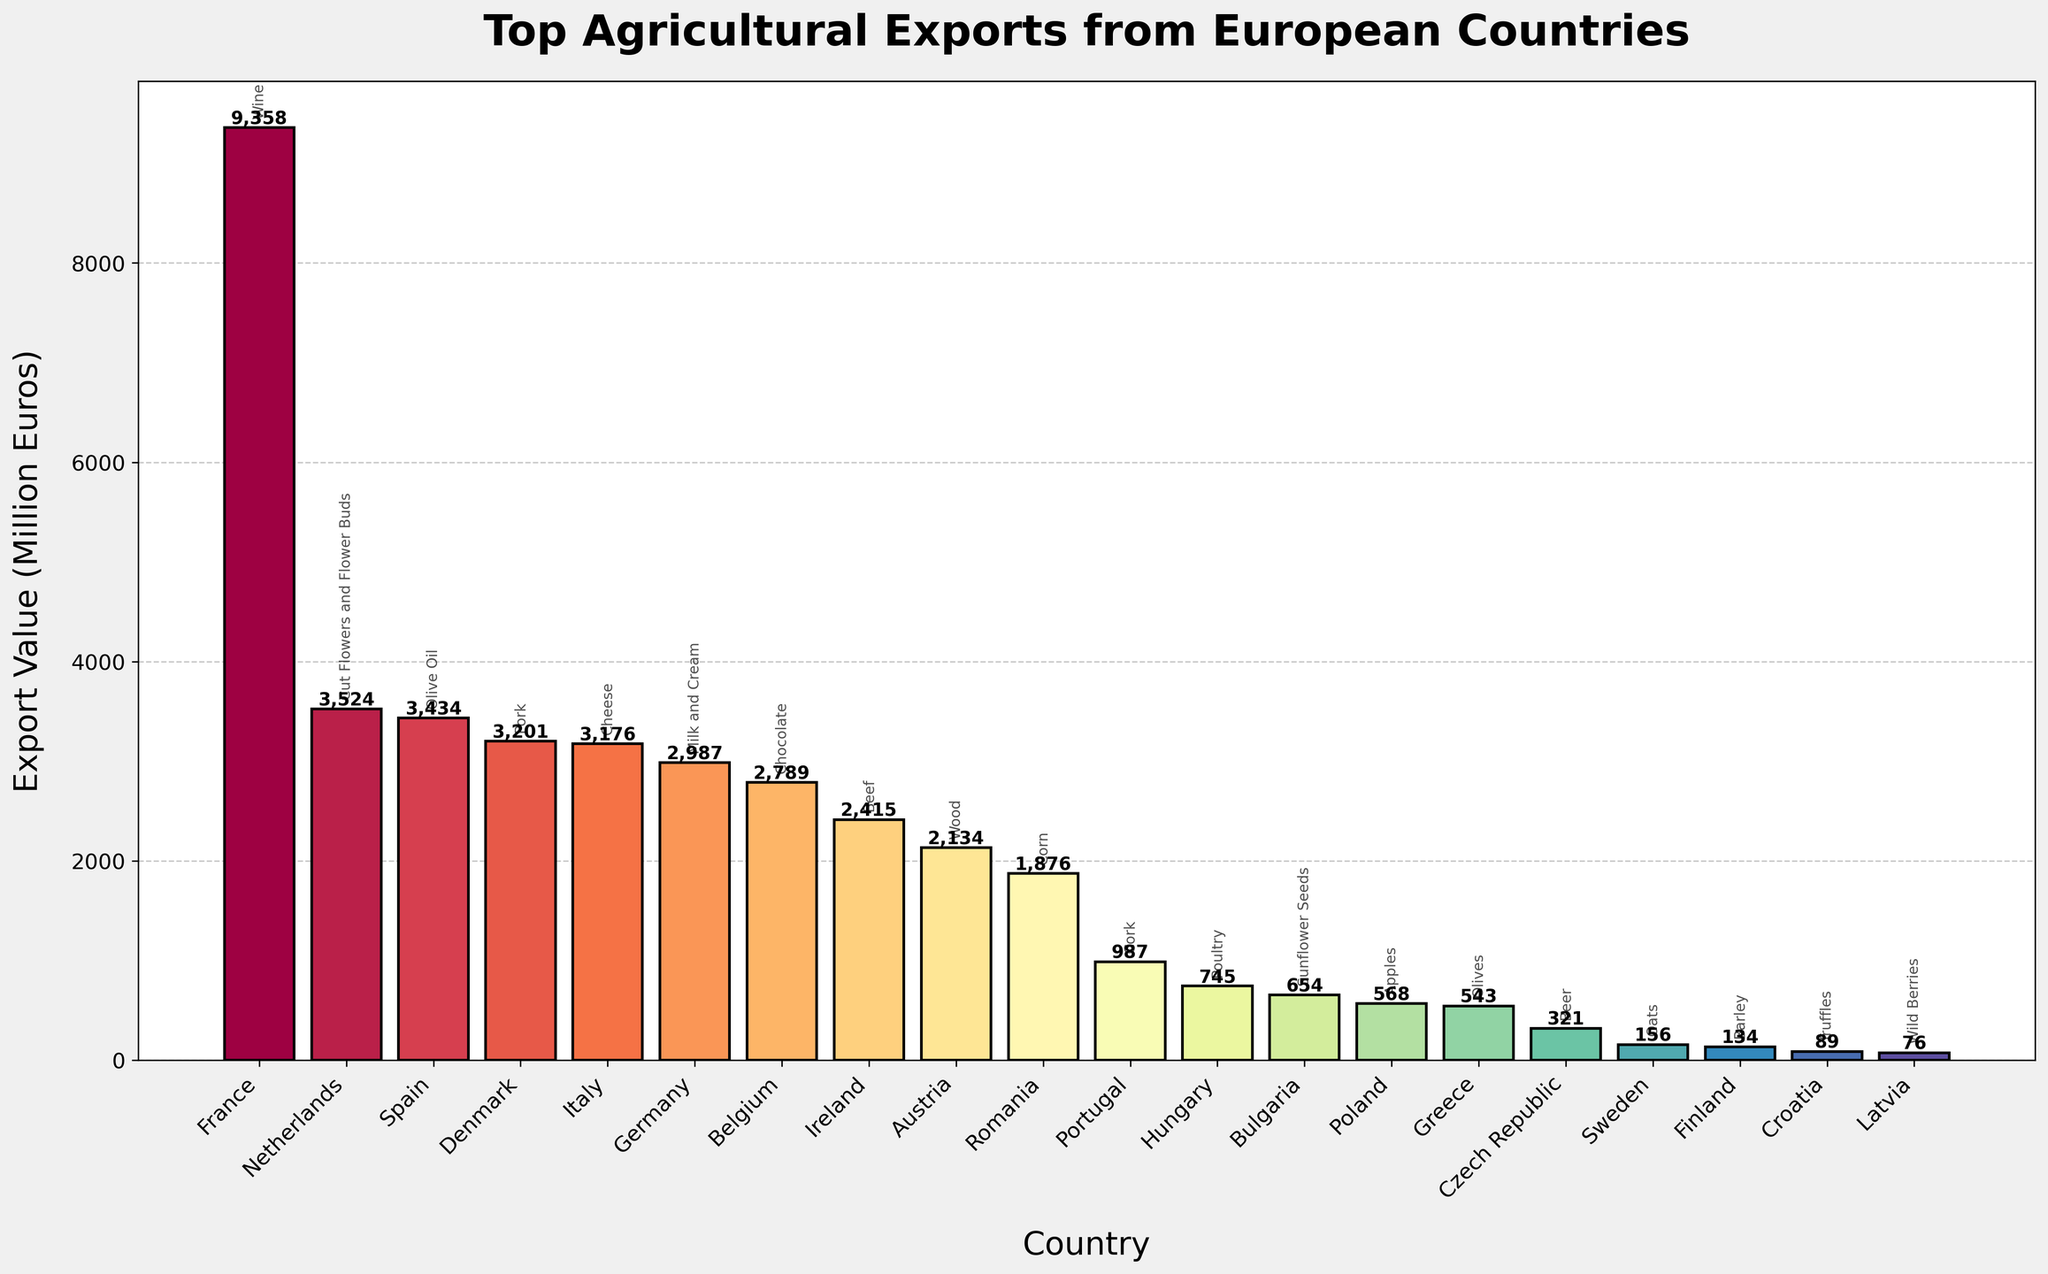Which country has the highest export value and what is the product? The top of the bar chart shows the country with the highest export value, and the product is annotated near the bar's tip. The first and highest bar corresponds to France with the product Wine.
Answer: France, Wine Which country exports the least valuable product and what is it? The lowest bar in the chart represents the least valuable export. The bar at the bottom corresponds to Latvia, exporting Wild Berries.
Answer: Latvia, Wild Berries What is the total export value of the top three countries? Identify the top three bars and sum their values. France (9358) + Netherlands (3524) + Spain (3434) = 16316.
Answer: 16316 Which agricultural product is exported by Germany and what is its export value? The bar labeled Germany has the product annotated near it as "Milk and Cream," with the export value of 2987 million euros.
Answer: Milk and Cream, 2987 million euros Between Poland and Portugal, which country has a higher export value and by how much? Compare the bars of Poland and Portugal. Poland has an export value of 568 million euros, and Portugal has 987 million euros. The difference is 987 - 568 = 419.
Answer: Portugal, 419 million euros How many countries have an export value greater than 3000 million euros? Count the bars with values greater than 3000 million euros. They are France, Netherlands, Spain, Denmark, and Italy, totaling five countries.
Answer: 5 What is the combined export value of countries exporting fruits (Apples, Olives, Wild Berries)? Sum the export values of Poland (Apples: 568), Greece (Olives: 543), and Latvia (Wild Berries: 76). 568 + 543 + 76 = 1187.
Answer: 1187 Which country exports chocolate and what is the corresponding export value? The bar labeled Belgium has the annotation "Chocolate," with an export value of 2789 million euros.
Answer: Belgium, 2789 million euros What is the average export value of Italy, Ireland, and Austria? Identify and sum the export values of Italy (3176), Ireland (2415), and Austria (2134), then divide by the number of countries. (3176 + 2415 + 2134) / 3 = 2575.
Answer: 2575 Which export product corresponds to the country with a light purple-colored bar? Scan for the bar with light purple color and identify its country. Denmark has a light purple-colored bar, and the annotation near it indicates the product as "Pork."
Answer: Pork 